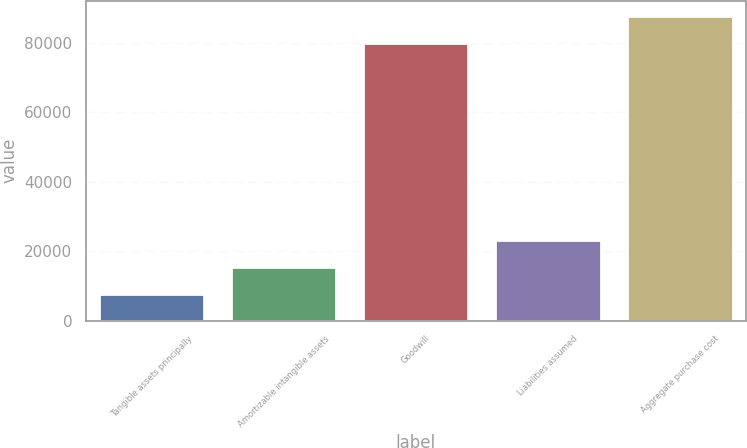Convert chart to OTSL. <chart><loc_0><loc_0><loc_500><loc_500><bar_chart><fcel>Tangible assets principally<fcel>Amortizable intangible assets<fcel>Goodwill<fcel>Liabilities assumed<fcel>Aggregate purchase cost<nl><fcel>7623<fcel>15485<fcel>79948<fcel>23347<fcel>87810<nl></chart> 